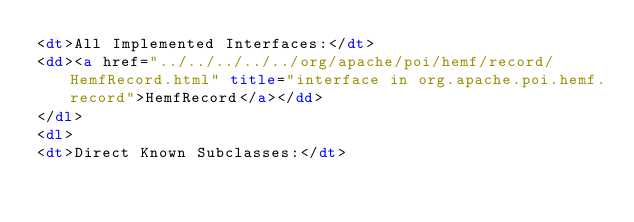<code> <loc_0><loc_0><loc_500><loc_500><_HTML_><dt>All Implemented Interfaces:</dt>
<dd><a href="../../../../../org/apache/poi/hemf/record/HemfRecord.html" title="interface in org.apache.poi.hemf.record">HemfRecord</a></dd>
</dl>
<dl>
<dt>Direct Known Subclasses:</dt></code> 